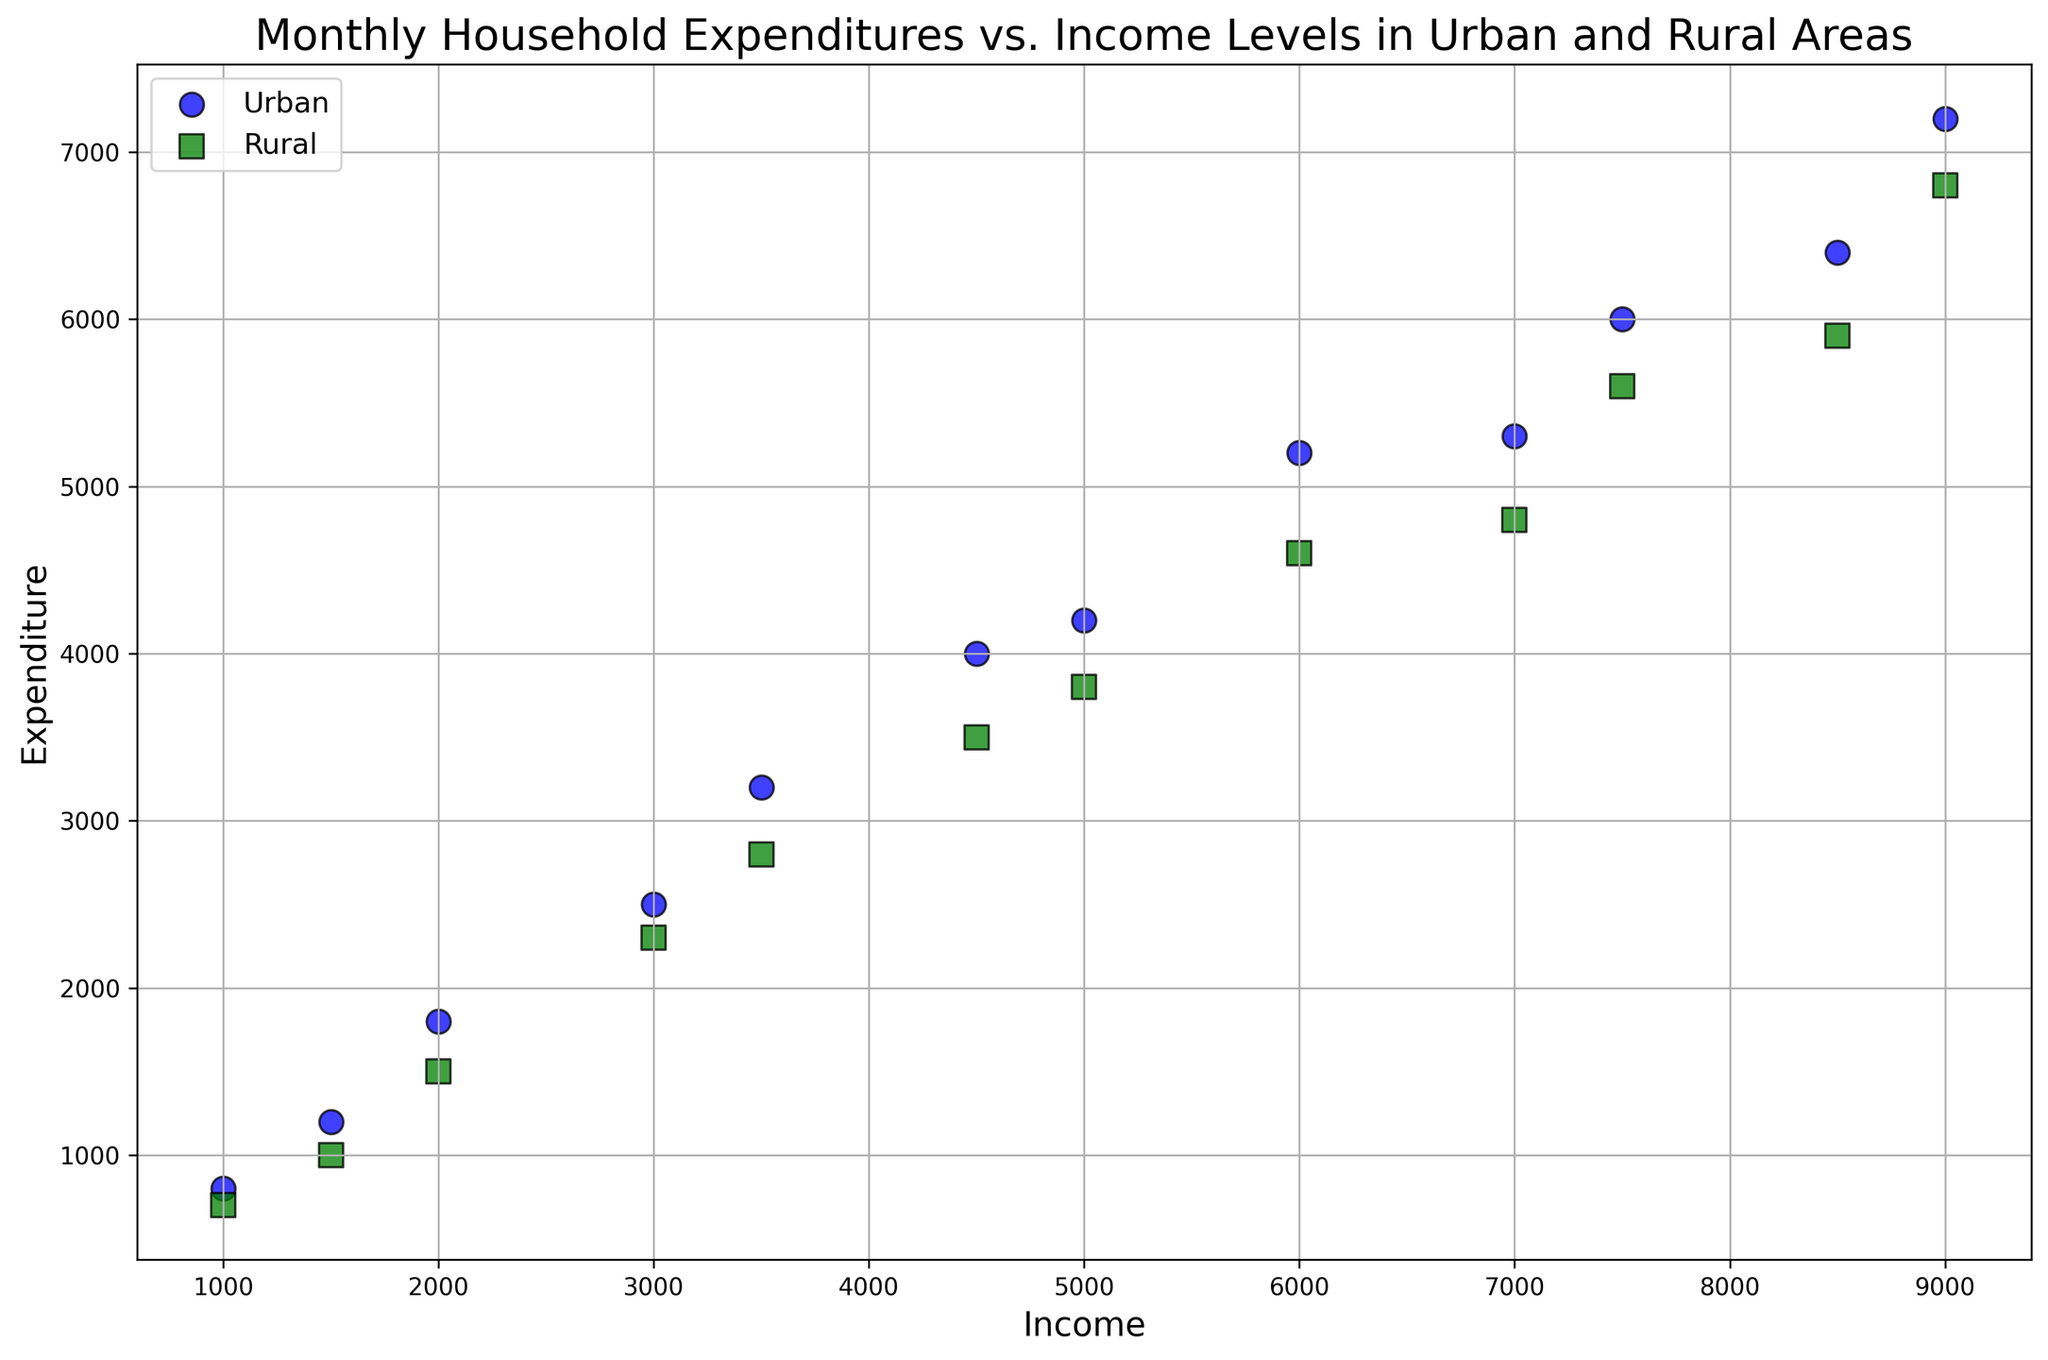What is the difference in expenditures between the highest-income urban household and the highest-income rural household? The highest-income urban household has an income of $9000 with an expenditure of $7200. The highest-income rural household also has an income of $9000 with an expenditure of $6800. The difference in expenditures is $7200 - $6800 = $400.
Answer: $400 Which area has the household with the lowest income, and what is that income? The scatter plot has a point representing the lowest income of $1000 in both Urban and Rural areas. To be specific, both areas show a household with this income level.
Answer: Both Urban and Rural What is the average expenditure of rural households with an income of $7000 to $9000? Two data points fall in this range for rural households: one with an expenditure of $4800 and another with $5900. The average is calculated by summing these expenditures: $4800 + $5900 = $10700, and then dividing by 2: $10700 / 2 = $5350.
Answer: $5350 Is there a visual trend indicating that urban households have higher expenditures than rural households for equivalent income levels? Observing the scatter plot, we see that for almost every income level shown, the expenditure associated with urban households is higher compared to rural households.
Answer: Yes What color is used to represent rural households in the scatter plot? The scatter plot uses green squares to represent rural households.
Answer: Green At an income level of $5000, how much more do urban households spend compared to rural households? At the $5000 income level, the urban household expenditure is $4200, and the rural household expenditure is $3800. The difference is $4200 - $3800 = $400.
Answer: $400 Are there any income levels where urban and rural expenditures are equal? Observing the scatter plot, there are no income levels where the expenditures of urban and rural households are the same.
Answer: No How many urban households have an income above $6000? There are three data points in the scatter plot for urban households with incomes above $6000: $7000, $7500, $9000.
Answer: 3 Which area shows a wider range of expenditures? Observing the scatter plot, urban households show a wider range of expenditures, from approximately $700 to $7200, compared to rural households, which range from $700 to $6800.
Answer: Urban 